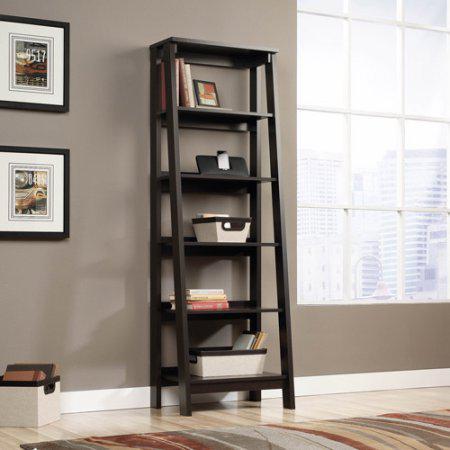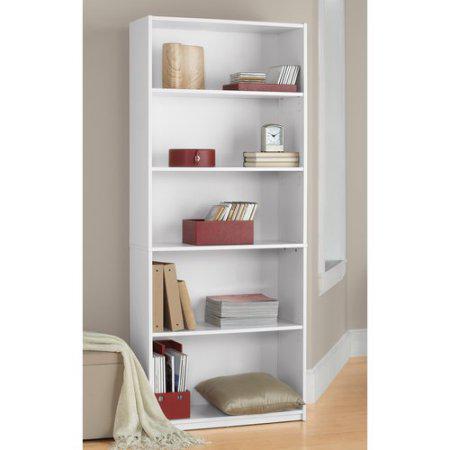The first image is the image on the left, the second image is the image on the right. Assess this claim about the two images: "One of the bookshelves is white.". Correct or not? Answer yes or no. Yes. 